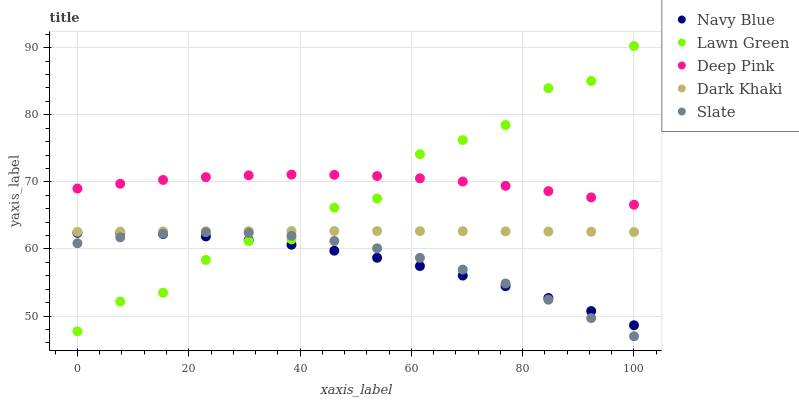Does Navy Blue have the minimum area under the curve?
Answer yes or no. Yes. Does Deep Pink have the maximum area under the curve?
Answer yes or no. Yes. Does Slate have the minimum area under the curve?
Answer yes or no. No. Does Slate have the maximum area under the curve?
Answer yes or no. No. Is Dark Khaki the smoothest?
Answer yes or no. Yes. Is Lawn Green the roughest?
Answer yes or no. Yes. Is Navy Blue the smoothest?
Answer yes or no. No. Is Navy Blue the roughest?
Answer yes or no. No. Does Slate have the lowest value?
Answer yes or no. Yes. Does Navy Blue have the lowest value?
Answer yes or no. No. Does Lawn Green have the highest value?
Answer yes or no. Yes. Does Slate have the highest value?
Answer yes or no. No. Is Navy Blue less than Deep Pink?
Answer yes or no. Yes. Is Deep Pink greater than Slate?
Answer yes or no. Yes. Does Dark Khaki intersect Lawn Green?
Answer yes or no. Yes. Is Dark Khaki less than Lawn Green?
Answer yes or no. No. Is Dark Khaki greater than Lawn Green?
Answer yes or no. No. Does Navy Blue intersect Deep Pink?
Answer yes or no. No. 